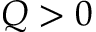<formula> <loc_0><loc_0><loc_500><loc_500>Q > 0</formula> 